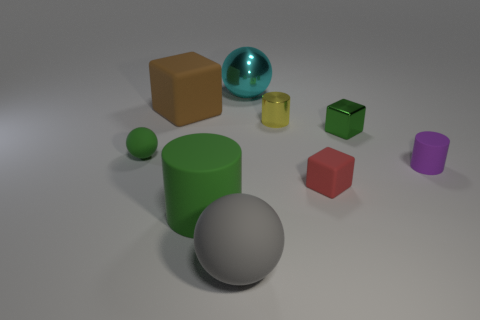Is the material of the ball on the left side of the big brown cube the same as the cube that is to the left of the gray sphere?
Your response must be concise. Yes. Are there fewer large gray objects that are to the left of the big brown rubber thing than brown shiny objects?
Give a very brief answer. No. The other matte thing that is the same shape as the tiny red object is what color?
Your response must be concise. Brown. Does the matte cube behind the metallic cylinder have the same size as the big gray thing?
Give a very brief answer. Yes. How big is the matte sphere that is to the left of the rubber ball that is in front of the small green matte ball?
Offer a terse response. Small. Does the green ball have the same material as the small thing that is in front of the small rubber cylinder?
Offer a very short reply. Yes. Are there fewer big metallic spheres that are behind the red thing than small green rubber things behind the small green shiny block?
Make the answer very short. No. There is another small cylinder that is made of the same material as the green cylinder; what is its color?
Your response must be concise. Purple. Are there any big matte objects that are behind the large ball that is in front of the big brown thing?
Offer a terse response. Yes. What color is the metallic cylinder that is the same size as the green rubber ball?
Keep it short and to the point. Yellow. 